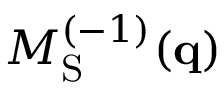<formula> <loc_0><loc_0><loc_500><loc_500>M _ { S } ^ { ( - 1 ) } ( q )</formula> 